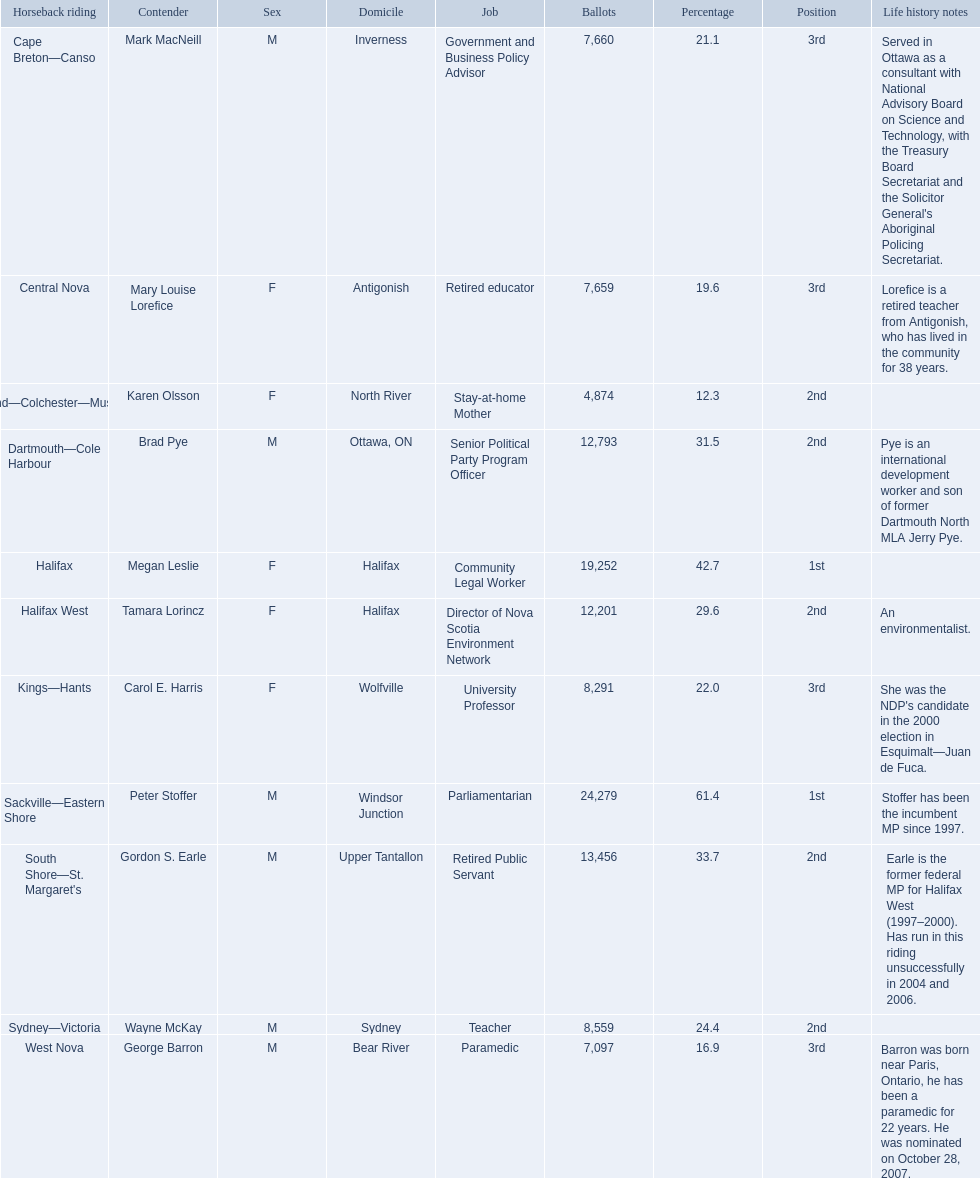Who were the new democratic party candidates, 2008? Mark MacNeill, Mary Louise Lorefice, Karen Olsson, Brad Pye, Megan Leslie, Tamara Lorincz, Carol E. Harris, Peter Stoffer, Gordon S. Earle, Wayne McKay, George Barron. Who had the 2nd highest number of votes? Megan Leslie, Peter Stoffer. How many votes did she receive? 19,252. 